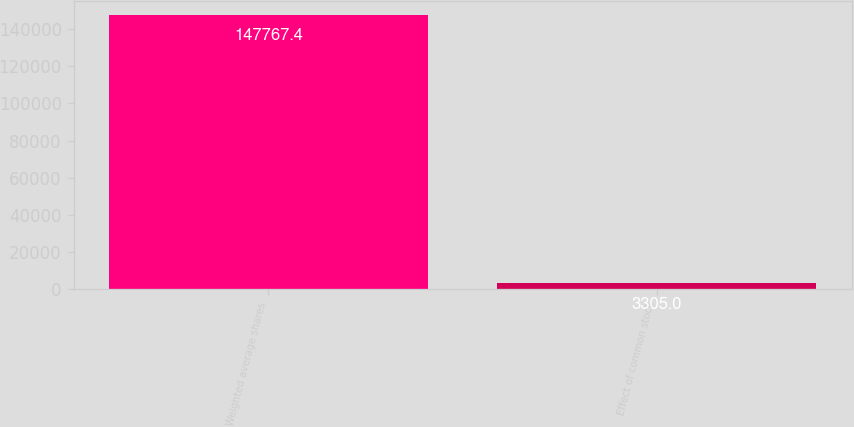Convert chart to OTSL. <chart><loc_0><loc_0><loc_500><loc_500><bar_chart><fcel>Weighted average shares<fcel>Effect of common stock<nl><fcel>147767<fcel>3305<nl></chart> 